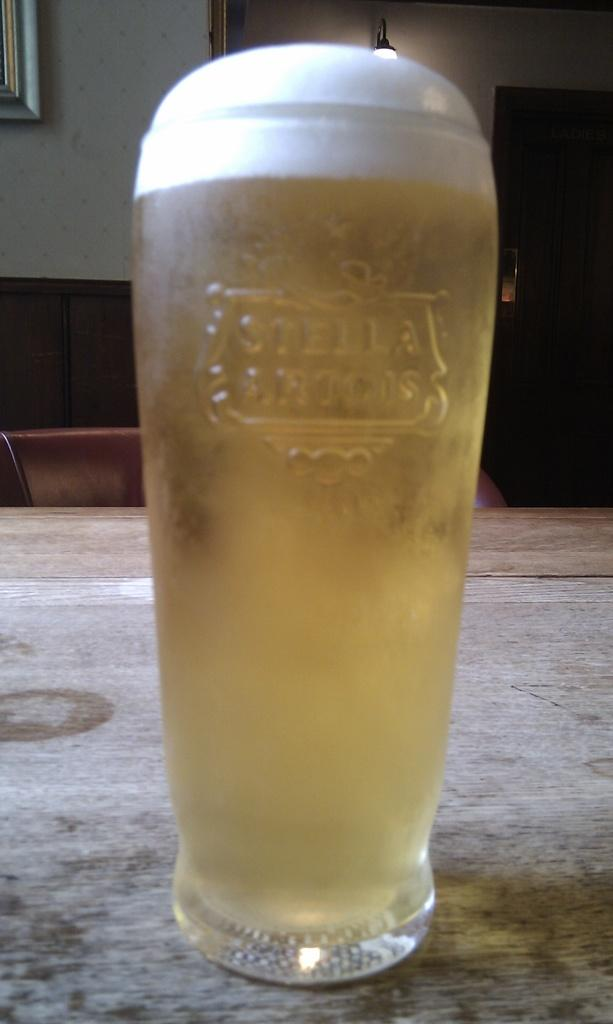<image>
Summarize the visual content of the image. An alcoholic beverage in a Stella Artois cup. 